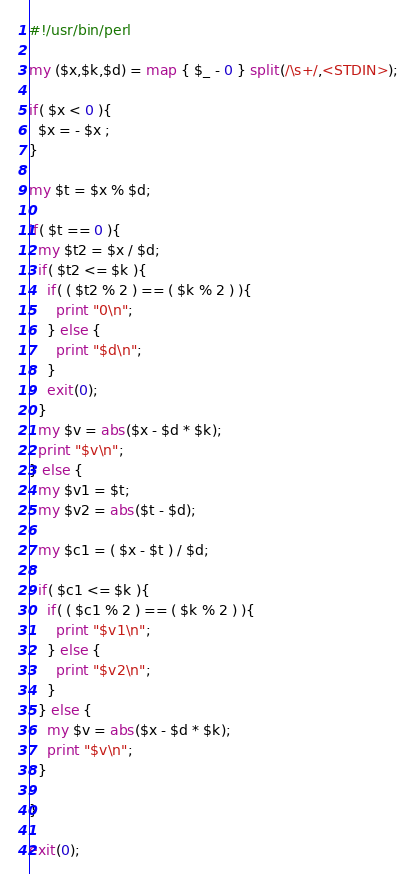Convert code to text. <code><loc_0><loc_0><loc_500><loc_500><_Perl_>#!/usr/bin/perl

my ($x,$k,$d) = map { $_ - 0 } split(/\s+/,<STDIN>);

if( $x < 0 ){
  $x = - $x ;
}

my $t = $x % $d;

if( $t == 0 ){
  my $t2 = $x / $d;
  if( $t2 <= $k ){
    if( ( $t2 % 2 ) == ( $k % 2 ) ){
      print "0\n";
    } else {
      print "$d\n";
    }
    exit(0);
  }
  my $v = abs($x - $d * $k);
  print "$v\n";
} else {
  my $v1 = $t;
  my $v2 = abs($t - $d);
  
  my $c1 = ( $x - $t ) / $d;
  
  if( $c1 <= $k ){
    if( ( $c1 % 2 ) == ( $k % 2 ) ){
      print "$v1\n";
    } else {
      print "$v2\n";
    }
  } else {
    my $v = abs($x - $d * $k);
    print "$v\n";
  }
  
}

exit(0);

</code> 